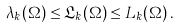Convert formula to latex. <formula><loc_0><loc_0><loc_500><loc_500>\lambda _ { k } ( \Omega ) \leq \mathfrak L _ { k } ( \Omega ) \leq L _ { k } ( \Omega ) \, .</formula> 